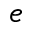<formula> <loc_0><loc_0><loc_500><loc_500>e</formula> 